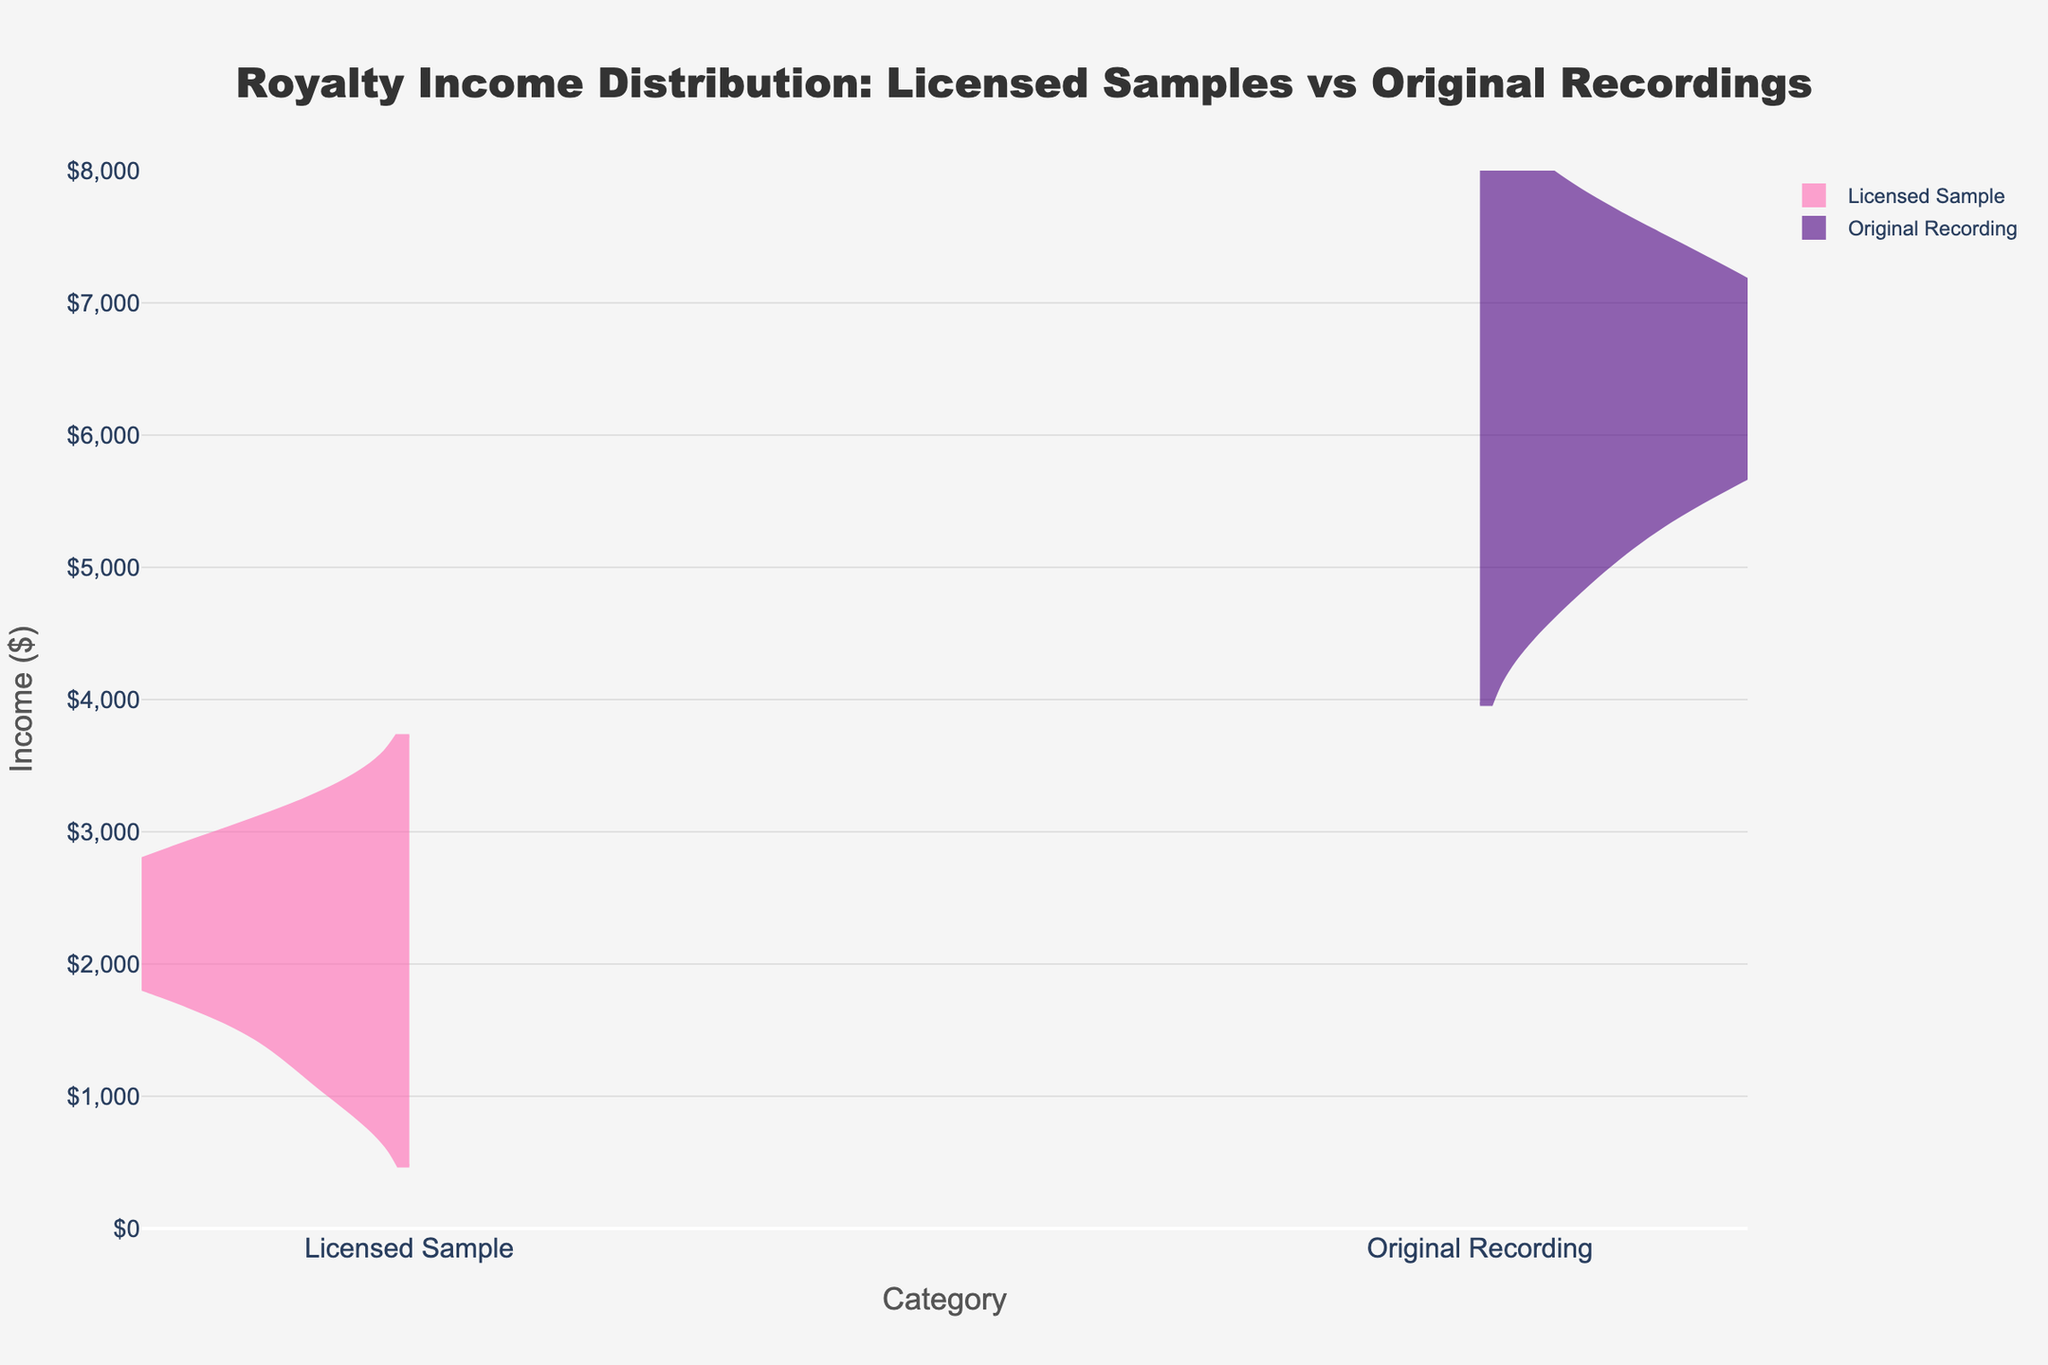What is the title of the figure? The title of the figure is located at the top of the plot, and it gives an overview of what the plot is about.
Answer: Royalty Income Distribution: Licensed Samples vs Original Recordings What is the range of incomes for licensed samples? The y-axis represents income in dollars, and we can observe the range of incomes for licensed samples by looking at the left side of the split violin.
Answer: $1200 to $3000 Which category has the higher median income? By comparing the middle points of each side of the split violin plot, we notice that the core or thickest region of the original recordings side is higher than that of the licensed samples side.
Answer: Original Recordings What is the highest income for original recordings? The right side of the split violin plot shows the income distribution for original recordings. By looking at the uppermost point, we find the highest income.
Answer: $7500 How many tracks are included in the original recordings category? We count the number of data points on the right side of the split violin plot for the original recordings category.
Answer: 8 What is the average income for licensed samples? Sum the incomes of licensed samples ($1200, $3000, $2500, $1800, $2200, $2700, $2000, $2300), and divide by the number of licensed samples (8).
Answer: $2212.50 Which category shows more variability in income distribution? The spread of the data points within each side of the split violin plot indicates variability. The licensed samples show a narrower range compared to original recordings, which has a broader spread.
Answer: Original Recordings What is the difference between the highest and lowest incomes in the original recordings category? Identify the highest income ($7500) and the lowest income ($5000) in the original recordings category, then subtract the lowest from the highest.
Answer: $2500 How does the skewness of the income distribution compare between licensed samples and original recordings? Look at the shape of the violins: licensed samples have more density towards the low end, suggesting a left (negative) skew, while original recordings show more even density distribution.
Answer: Licensed samples are more left-skewed Which category has more frequently occurring income values? By examining the density and thickness of the violins in each category, we see that original recordings have a thicker middle section, indicating more frequent mid-range income values.
Answer: Original Recordings 